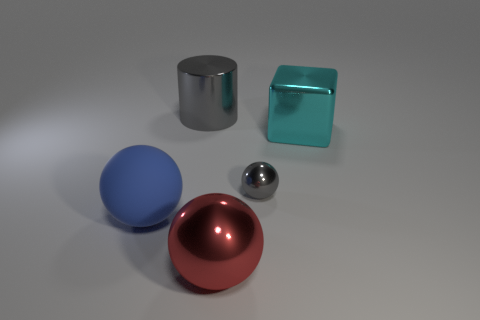How many objects are gray objects that are behind the cube or big objects that are in front of the big block?
Provide a short and direct response. 3. There is a metallic sphere on the right side of the red ball; is its color the same as the metallic sphere on the left side of the gray metal ball?
Make the answer very short. No. There is a thing that is right of the gray cylinder and behind the gray metallic ball; what shape is it?
Offer a terse response. Cube. The cylinder that is the same size as the red thing is what color?
Your answer should be very brief. Gray. Are there any tiny balls that have the same color as the block?
Keep it short and to the point. No. There is a gray object that is behind the big block; is its size the same as the gray object that is on the right side of the large gray cylinder?
Provide a short and direct response. No. There is a large object that is behind the large metal sphere and in front of the big cyan shiny cube; what is its material?
Keep it short and to the point. Rubber. There is a shiny ball that is the same color as the cylinder; what is its size?
Your answer should be very brief. Small. How many other objects are there of the same size as the cyan object?
Offer a terse response. 3. What material is the sphere on the left side of the red sphere?
Ensure brevity in your answer.  Rubber. 